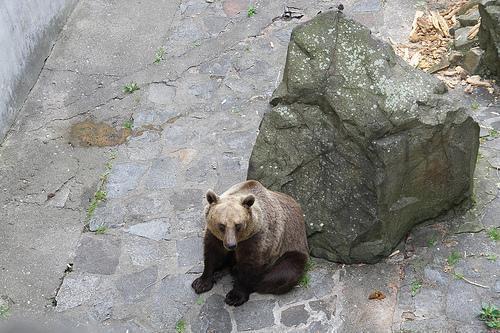How many bears?
Give a very brief answer. 1. 